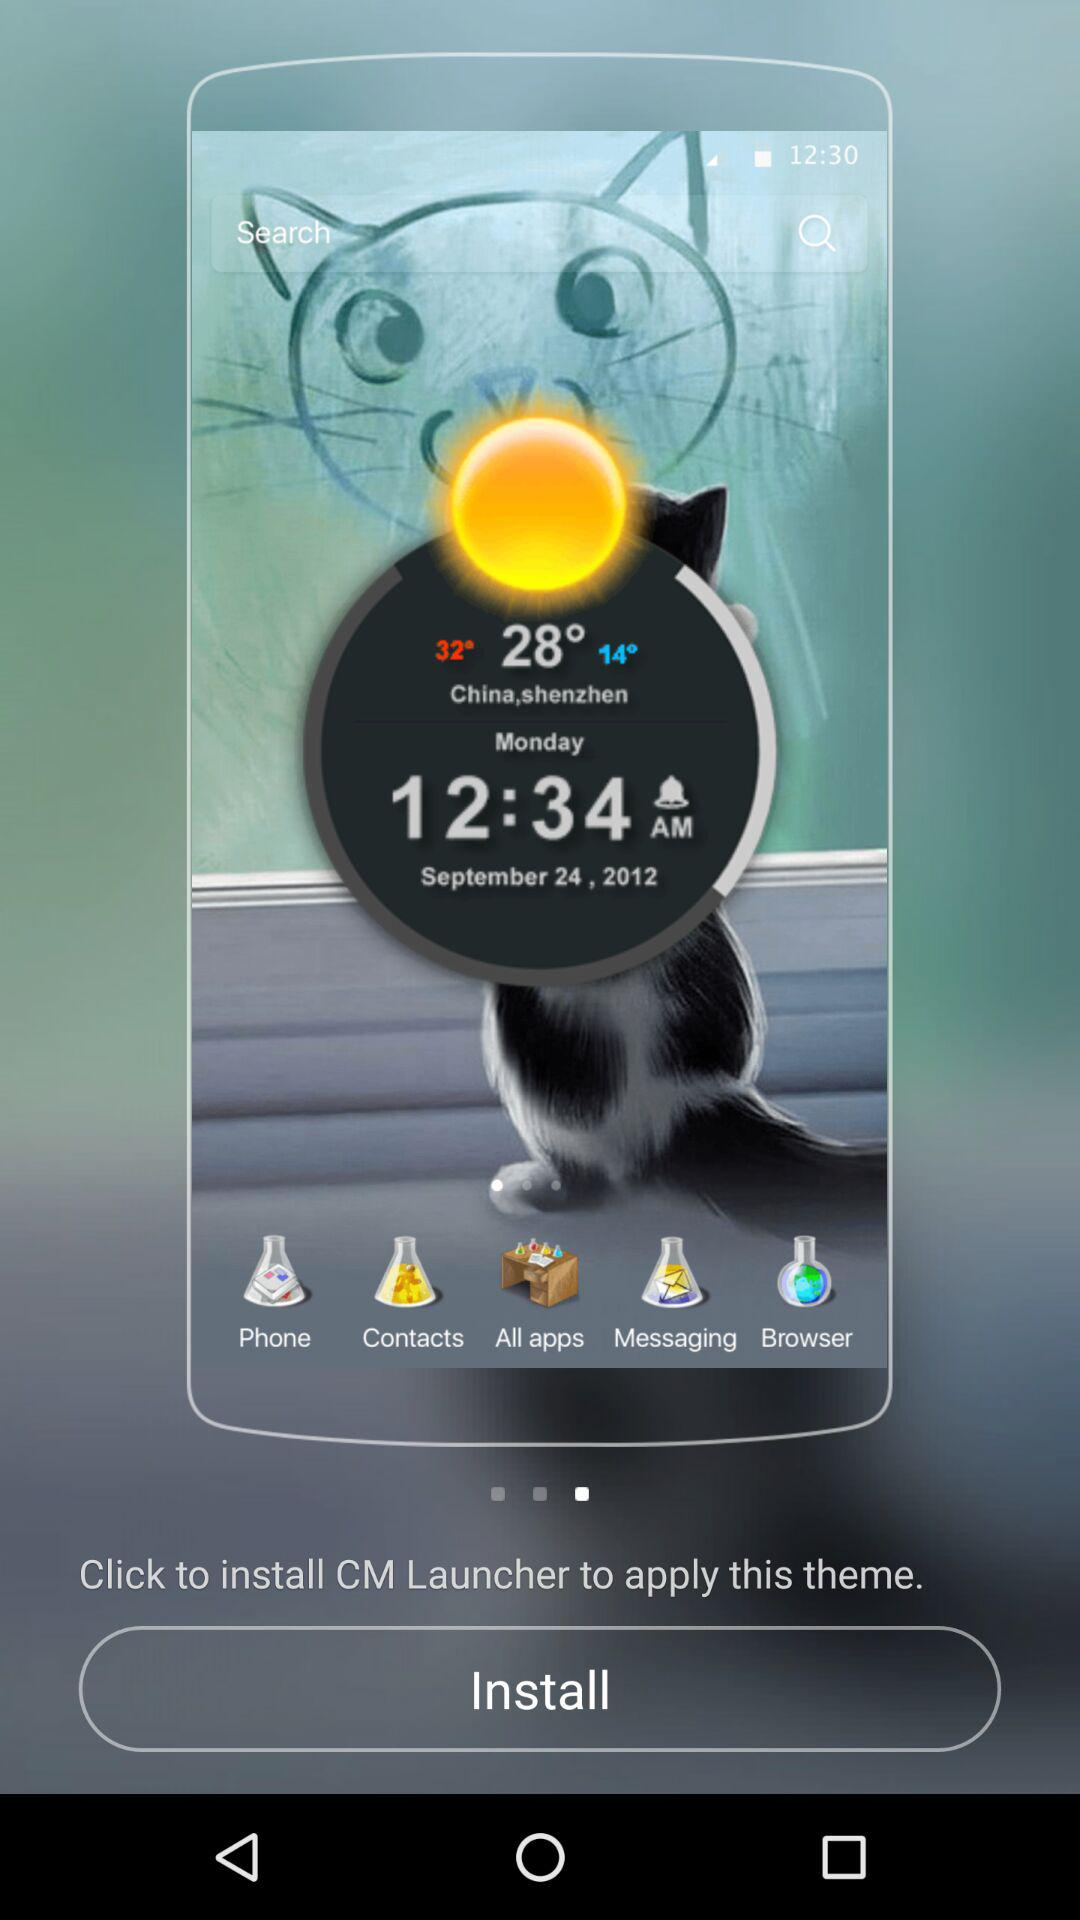What is the lowest temperature? The lowest temperature is 14°. 